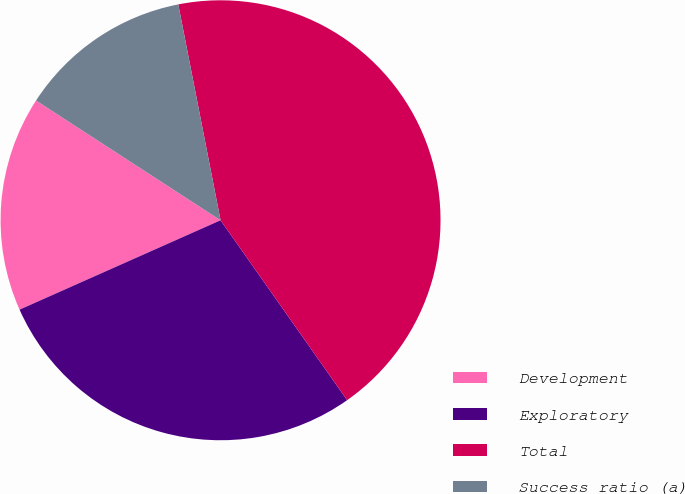Convert chart to OTSL. <chart><loc_0><loc_0><loc_500><loc_500><pie_chart><fcel>Development<fcel>Exploratory<fcel>Total<fcel>Success ratio (a)<nl><fcel>15.82%<fcel>28.1%<fcel>43.32%<fcel>12.76%<nl></chart> 